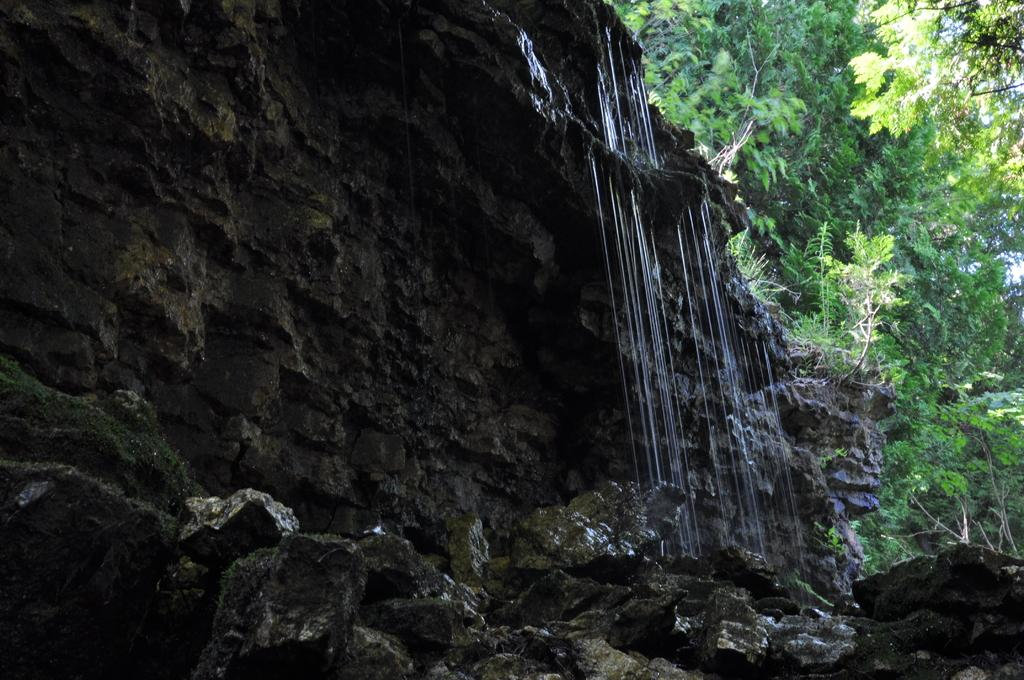What natural feature is the main subject of the image? There is a waterfall in the image. What type of vegetation can be seen in the image? There are trees in the image. What type of loaf is being baked in the waterfall? There is no loaf or baking activity present in the image, as it features a waterfall and trees. 